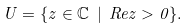Convert formula to latex. <formula><loc_0><loc_0><loc_500><loc_500>U = \{ z \in \mathbb { C } \ | \ R e z > 0 \} .</formula> 